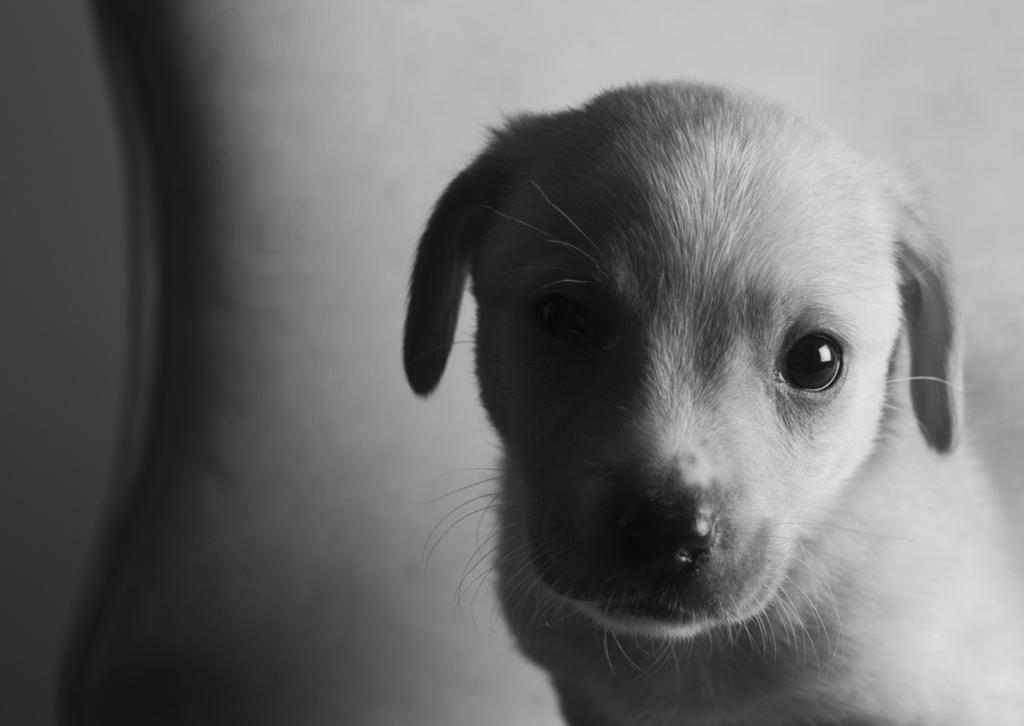What is the main subject of the image? The main subject of the image is a dog's face. Are there any fairies taking care of the dog in the image? There are no fairies present in the image, and the dog's care is not mentioned or depicted. 